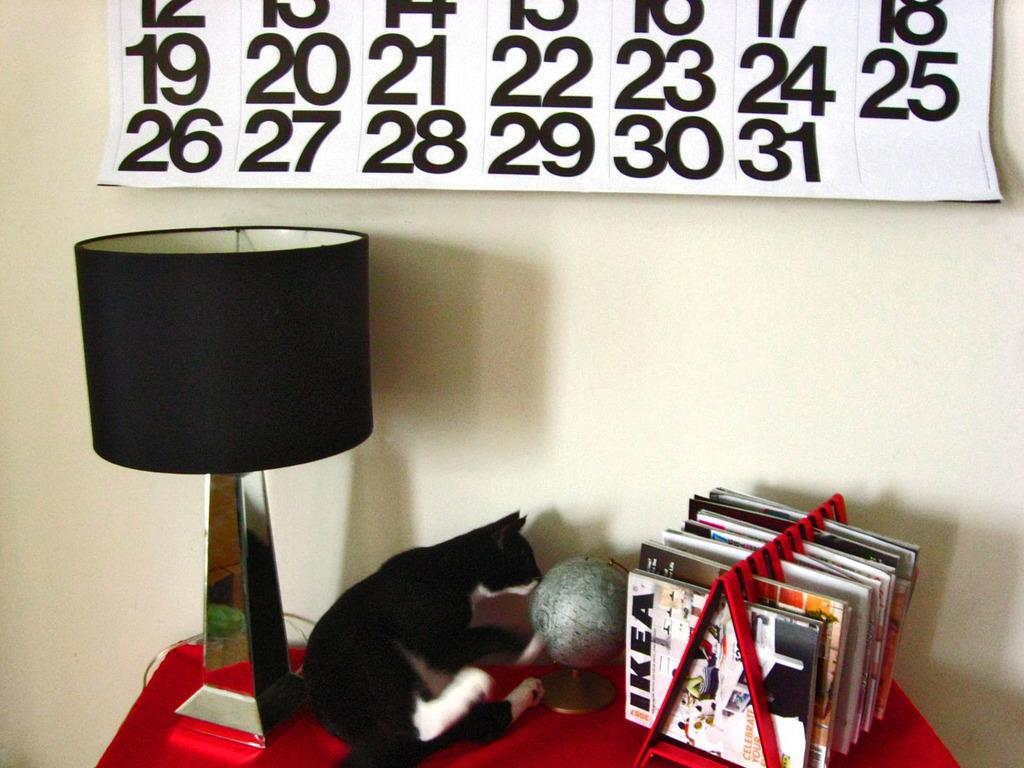What is the main object on the wall in the image? There is a calendar in the image. What color is the table that the lamp is on? The table is red. What type of animal can be seen in the image? A cat is visible in the image. What object is used for displaying the Earth in the image? There is a globe in the image. What type of items are on the table? There are books on the table. What is visible in the background of the image? There is a wall in the background of the image. What number is being protested by the cat in the image? There is no protest or number present in the image; it features a cat, a calendar, a lamp, a red table, books, a globe, and a wall. What type of material is the silver used for in the image? There is no silver present in the image. 